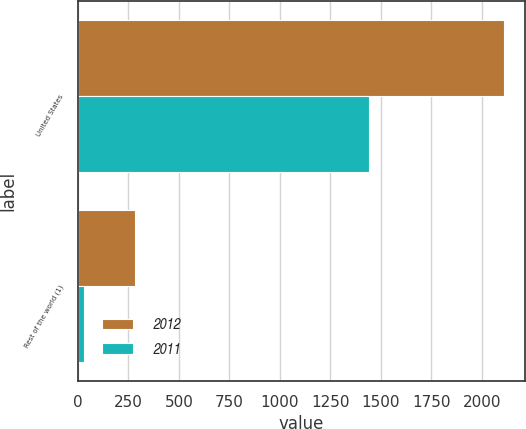<chart> <loc_0><loc_0><loc_500><loc_500><stacked_bar_chart><ecel><fcel>United States<fcel>Rest of the world (1)<nl><fcel>2012<fcel>2110<fcel>281<nl><fcel>2011<fcel>1444<fcel>31<nl></chart> 